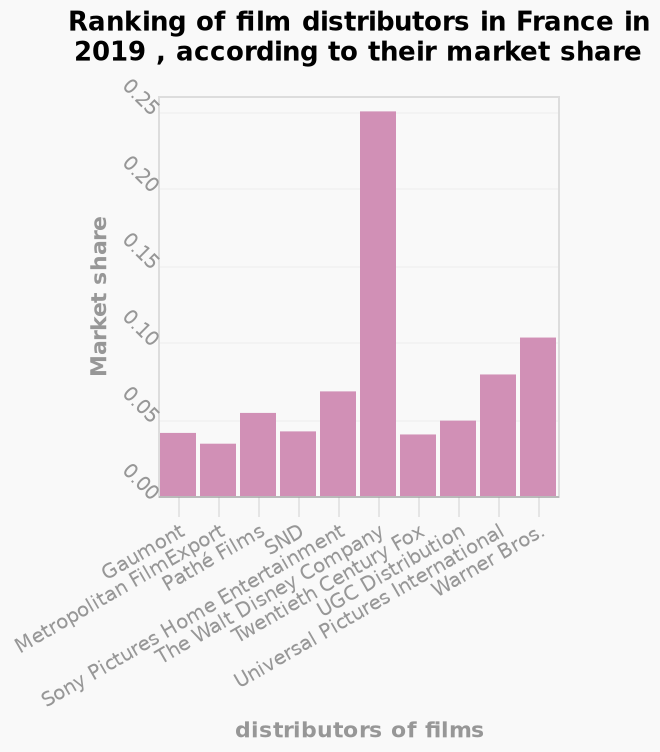<image>
please summary the statistics and relations of the chart The Walt Disney Company has the highest market share at 0.25. What period does the bar graph cover? The bar graph covers the year 2019 in France. Describe the following image in detail Here a is a bar graph titled Ranking of film distributors in France in 2019 , according to their market share. The x-axis shows distributors of films while the y-axis shows Market share. 